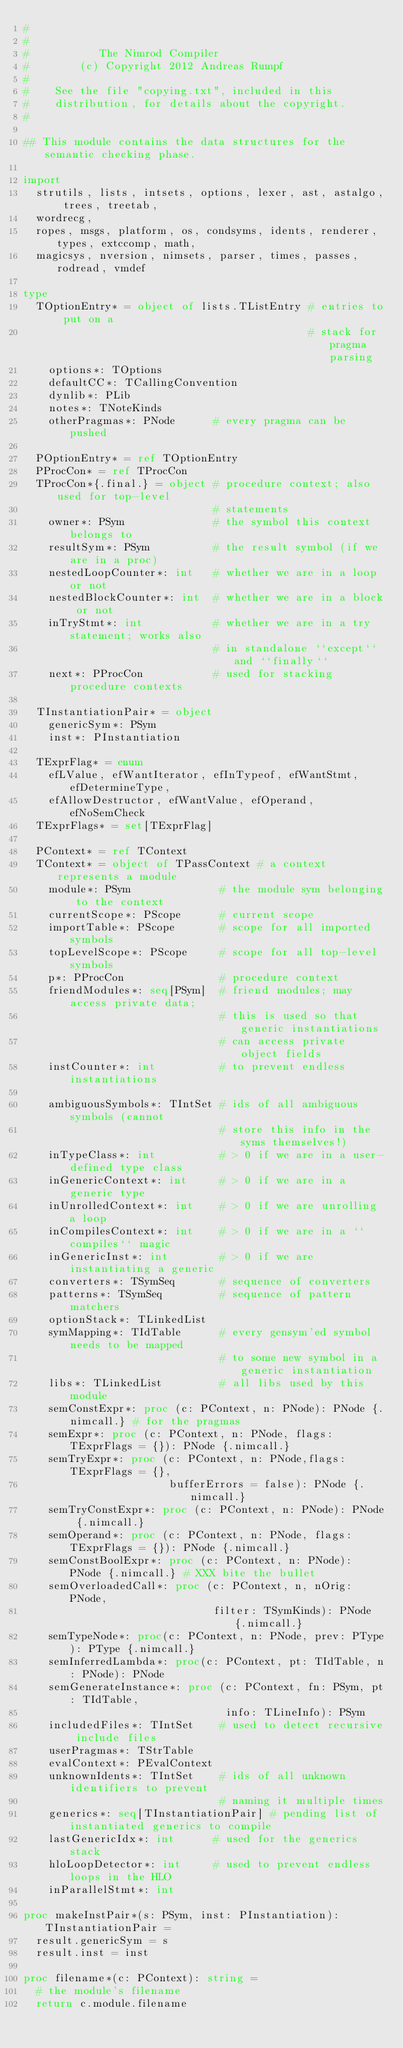<code> <loc_0><loc_0><loc_500><loc_500><_Nim_>#
#
#           The Nimrod Compiler
#        (c) Copyright 2012 Andreas Rumpf
#
#    See the file "copying.txt", included in this
#    distribution, for details about the copyright.
#

## This module contains the data structures for the semantic checking phase.

import 
  strutils, lists, intsets, options, lexer, ast, astalgo, trees, treetab,
  wordrecg, 
  ropes, msgs, platform, os, condsyms, idents, renderer, types, extccomp, math, 
  magicsys, nversion, nimsets, parser, times, passes, rodread, vmdef

type 
  TOptionEntry* = object of lists.TListEntry # entries to put on a
                                             # stack for pragma parsing
    options*: TOptions
    defaultCC*: TCallingConvention
    dynlib*: PLib
    notes*: TNoteKinds
    otherPragmas*: PNode      # every pragma can be pushed

  POptionEntry* = ref TOptionEntry
  PProcCon* = ref TProcCon
  TProcCon*{.final.} = object # procedure context; also used for top-level
                              # statements
    owner*: PSym              # the symbol this context belongs to
    resultSym*: PSym          # the result symbol (if we are in a proc)
    nestedLoopCounter*: int   # whether we are in a loop or not
    nestedBlockCounter*: int  # whether we are in a block or not
    inTryStmt*: int           # whether we are in a try statement; works also
                              # in standalone ``except`` and ``finally``
    next*: PProcCon           # used for stacking procedure contexts
  
  TInstantiationPair* = object
    genericSym*: PSym
    inst*: PInstantiation

  TExprFlag* = enum 
    efLValue, efWantIterator, efInTypeof, efWantStmt, efDetermineType,
    efAllowDestructor, efWantValue, efOperand, efNoSemCheck
  TExprFlags* = set[TExprFlag]

  PContext* = ref TContext
  TContext* = object of TPassContext # a context represents a module
    module*: PSym              # the module sym belonging to the context
    currentScope*: PScope      # current scope
    importTable*: PScope       # scope for all imported symbols
    topLevelScope*: PScope     # scope for all top-level symbols
    p*: PProcCon               # procedure context
    friendModules*: seq[PSym]  # friend modules; may access private data;
                               # this is used so that generic instantiations
                               # can access private object fields
    instCounter*: int          # to prevent endless instantiations
   
    ambiguousSymbols*: TIntSet # ids of all ambiguous symbols (cannot
                               # store this info in the syms themselves!)
    inTypeClass*: int          # > 0 if we are in a user-defined type class
    inGenericContext*: int     # > 0 if we are in a generic type
    inUnrolledContext*: int    # > 0 if we are unrolling a loop
    inCompilesContext*: int    # > 0 if we are in a ``compiles`` magic
    inGenericInst*: int        # > 0 if we are instantiating a generic
    converters*: TSymSeq       # sequence of converters
    patterns*: TSymSeq         # sequence of pattern matchers
    optionStack*: TLinkedList
    symMapping*: TIdTable      # every gensym'ed symbol needs to be mapped
                               # to some new symbol in a generic instantiation
    libs*: TLinkedList         # all libs used by this module
    semConstExpr*: proc (c: PContext, n: PNode): PNode {.nimcall.} # for the pragmas
    semExpr*: proc (c: PContext, n: PNode, flags: TExprFlags = {}): PNode {.nimcall.}
    semTryExpr*: proc (c: PContext, n: PNode,flags: TExprFlags = {},
                       bufferErrors = false): PNode {.nimcall.}
    semTryConstExpr*: proc (c: PContext, n: PNode): PNode {.nimcall.}
    semOperand*: proc (c: PContext, n: PNode, flags: TExprFlags = {}): PNode {.nimcall.}
    semConstBoolExpr*: proc (c: PContext, n: PNode): PNode {.nimcall.} # XXX bite the bullet
    semOverloadedCall*: proc (c: PContext, n, nOrig: PNode,
                              filter: TSymKinds): PNode {.nimcall.}
    semTypeNode*: proc(c: PContext, n: PNode, prev: PType): PType {.nimcall.}
    semInferredLambda*: proc(c: PContext, pt: TIdTable, n: PNode): PNode
    semGenerateInstance*: proc (c: PContext, fn: PSym, pt: TIdTable,
                                info: TLineInfo): PSym
    includedFiles*: TIntSet    # used to detect recursive include files
    userPragmas*: TStrTable
    evalContext*: PEvalContext
    unknownIdents*: TIntSet    # ids of all unknown identifiers to prevent
                               # naming it multiple times
    generics*: seq[TInstantiationPair] # pending list of instantiated generics to compile
    lastGenericIdx*: int      # used for the generics stack
    hloLoopDetector*: int     # used to prevent endless loops in the HLO
    inParallelStmt*: int
   
proc makeInstPair*(s: PSym, inst: PInstantiation): TInstantiationPair =
  result.genericSym = s
  result.inst = inst

proc filename*(c: PContext): string =
  # the module's filename
  return c.module.filename
</code> 